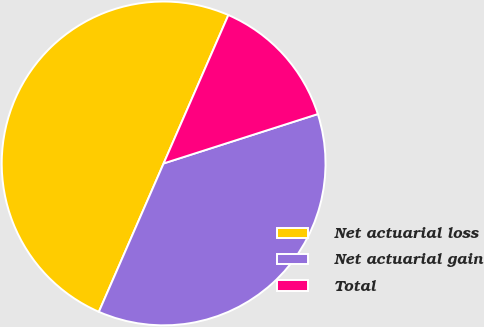Convert chart to OTSL. <chart><loc_0><loc_0><loc_500><loc_500><pie_chart><fcel>Net actuarial loss<fcel>Net actuarial gain<fcel>Total<nl><fcel>50.0%<fcel>36.48%<fcel>13.52%<nl></chart> 